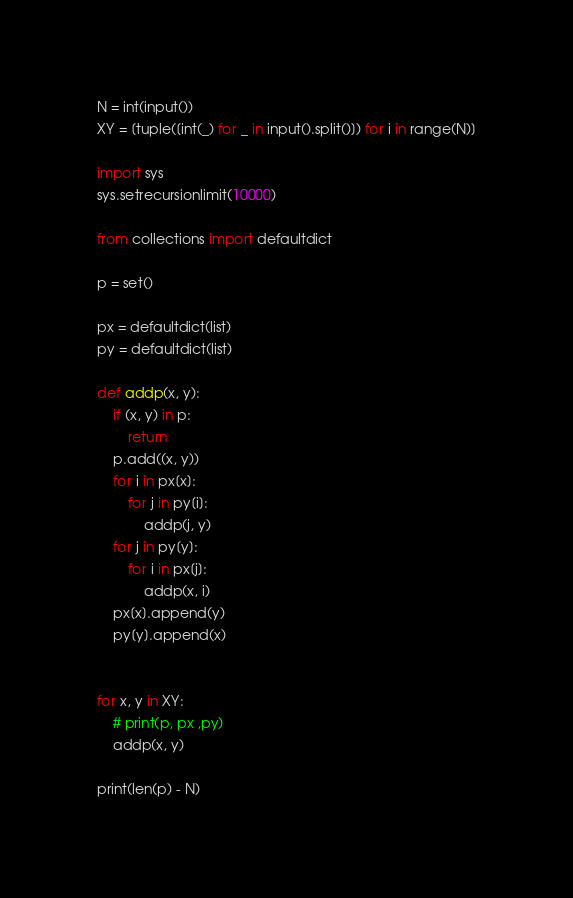Convert code to text. <code><loc_0><loc_0><loc_500><loc_500><_Python_>N = int(input())
XY = [tuple([int(_) for _ in input().split()]) for i in range(N)]

import sys
sys.setrecursionlimit(10000)

from collections import defaultdict

p = set()

px = defaultdict(list)
py = defaultdict(list)

def addp(x, y):
    if (x, y) in p:
        return
    p.add((x, y))
    for i in px[x]:
        for j in py[i]:
            addp(j, y)
    for j in py[y]:
        for i in px[j]:
            addp(x, i)
    px[x].append(y)
    py[y].append(x)


for x, y in XY:
    # print(p, px ,py)
    addp(x, y)

print(len(p) - N)
</code> 